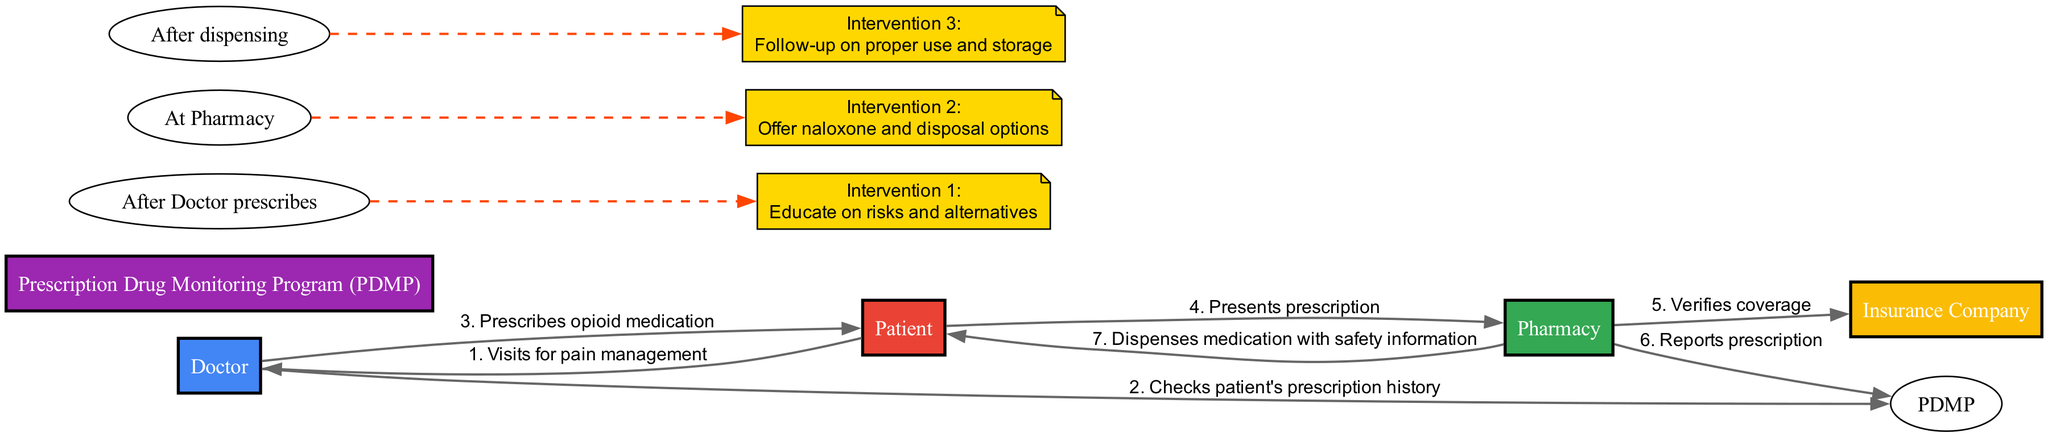What is the first action in the sequence? The first action in the sequence is when the Patient visits the Doctor for pain management. This can be determined by looking at the first entry in the sequence, where the Patient is the initiating actor.
Answer: Patient visits for pain management How many actors are involved in this diagram? There are five actors listed in the diagram: Doctor, Patient, Pharmacy, Insurance Company, and Prescription Drug Monitoring Program. Therefore, counting these distinct entities provides the total number of actors.
Answer: 5 What happens after the Doctor prescribes medication? After the Doctor prescribes medication, the Patient presents the prescription to the Pharmacy. This is the immediate next step in the sequence, indicating the flow of the prescription process.
Answer: Patient presents prescription Which actor is responsible for verification of coverage? The actor responsible for verification of coverage is the Pharmacy. This action is confirmed by the specific step in the sequence where the Pharmacy communicates with the Insurance Company to verify the patient's insurance coverage.
Answer: Pharmacy What intervention occurs at the Pharmacy? The intervention that occurs at the Pharmacy is the offering of naloxone and disposal options. This is noted as a specific action listed in the interventions section, which highlights what support services can be provided at that stage.
Answer: Offer naloxone and disposal options What are the total actions reported in the sequence? The total actions reported in the sequence consist of the steps taken from the Patient to the Doctor, and then through to the Pharmacy and other actors, leading to a total of six distinct actions noted in the sequence.
Answer: 6 What does the Prescription Drug Monitoring Program check? The Prescription Drug Monitoring Program checks the patient's prescription history. This action is specified in the sequence where the Doctor interacts with the PDMP to ensure safe prescribing practices.
Answer: Checks patient's prescription history What is the last action shown in the sequence? The last action shown in the sequence is when the Pharmacy dispenses medication with safety information to the Patient. This indicates the final step in the process of the opioid prescription journey before it reaches the Patient.
Answer: Dispenses medication with safety information What is the action that occurs after dispensing the medication? The action that occurs after dispensing the medication is a follow-up on proper use and storage. This is identified as a critical intervention listed after the dispensing step to ensure patient safety and effective medication management.
Answer: Follow-up on proper use and storage 